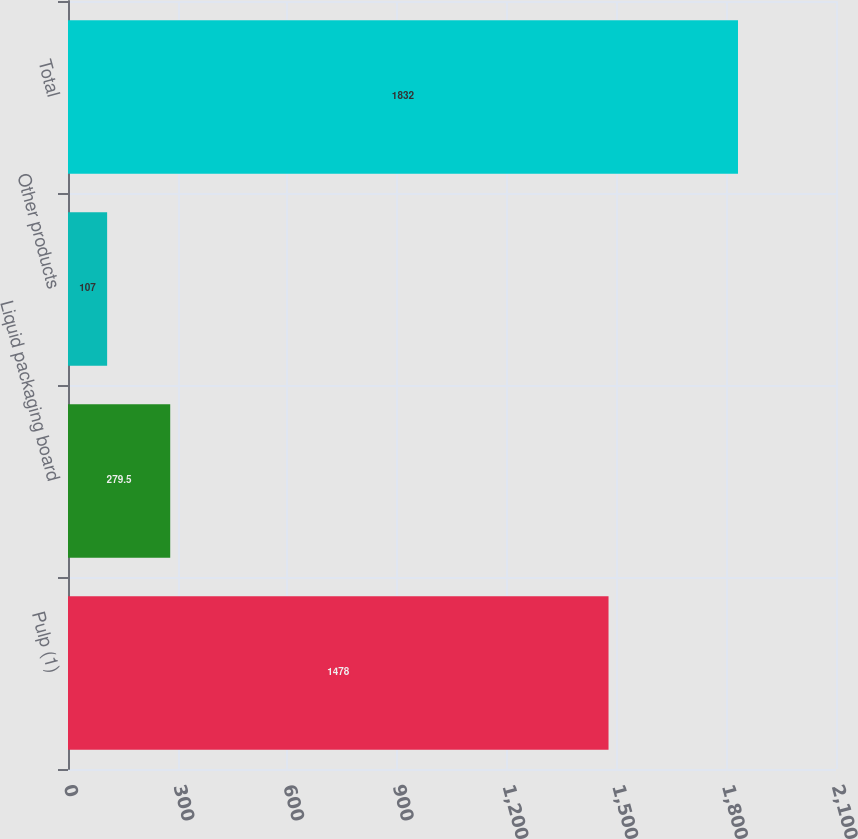Convert chart. <chart><loc_0><loc_0><loc_500><loc_500><bar_chart><fcel>Pulp (1)<fcel>Liquid packaging board<fcel>Other products<fcel>Total<nl><fcel>1478<fcel>279.5<fcel>107<fcel>1832<nl></chart> 